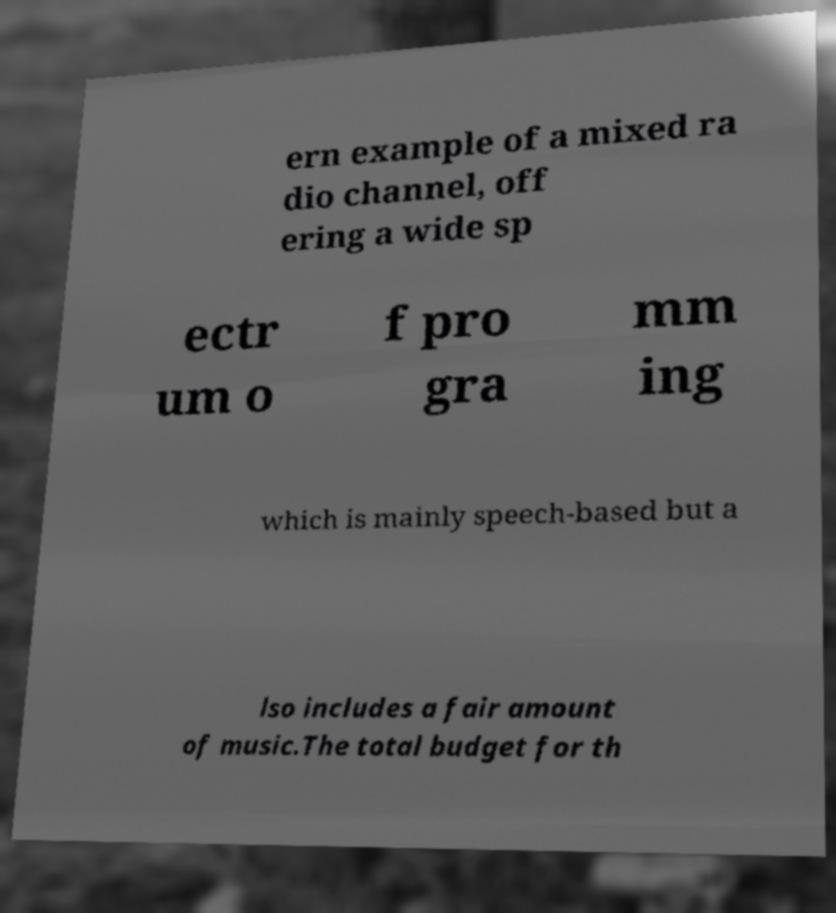Can you accurately transcribe the text from the provided image for me? ern example of a mixed ra dio channel, off ering a wide sp ectr um o f pro gra mm ing which is mainly speech-based but a lso includes a fair amount of music.The total budget for th 